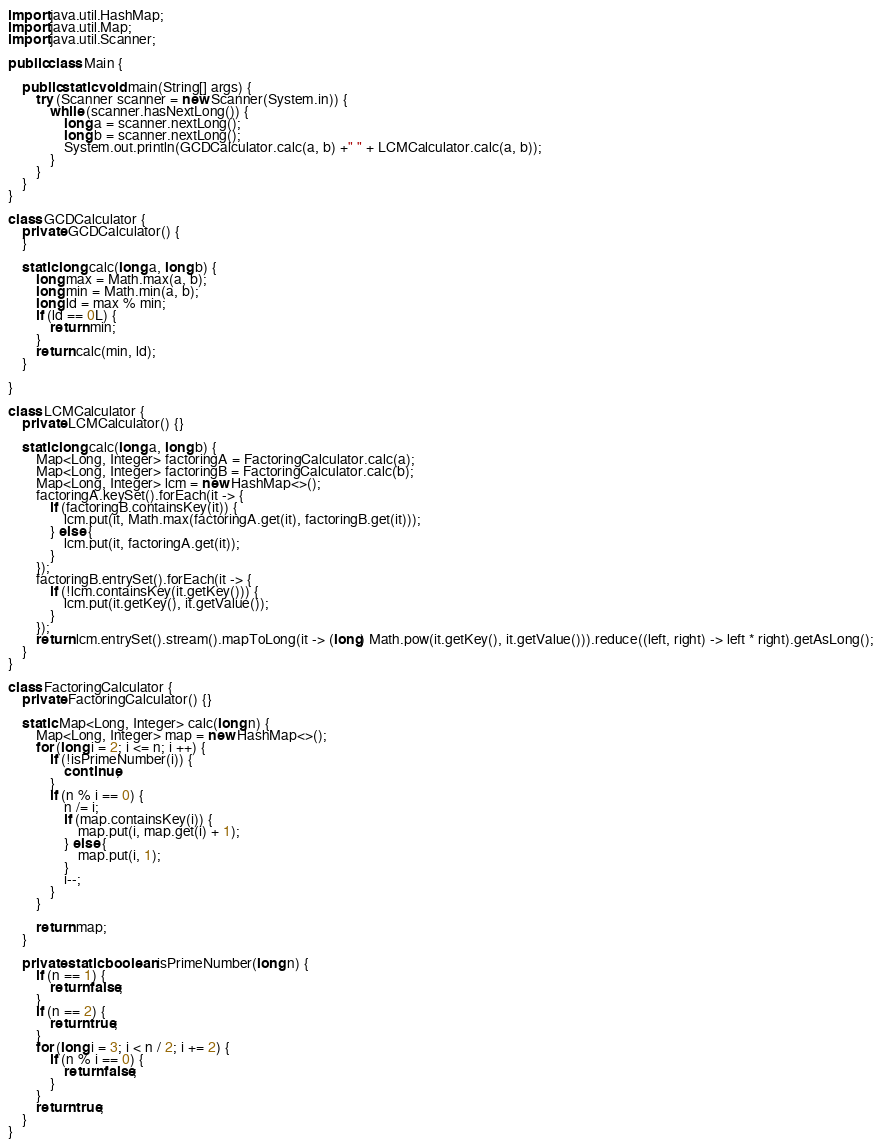<code> <loc_0><loc_0><loc_500><loc_500><_Java_>import java.util.HashMap;
import java.util.Map;
import java.util.Scanner;

public class Main {

    public static void main(String[] args) {
        try (Scanner scanner = new Scanner(System.in)) {
            while (scanner.hasNextLong()) {
                long a = scanner.nextLong();
                long b = scanner.nextLong();
                System.out.println(GCDCalculator.calc(a, b) +" " + LCMCalculator.calc(a, b));
            }
        }
    }
}

class GCDCalculator {
    private GCDCalculator() {
    }

    static long calc(long a, long b) {
        long max = Math.max(a, b);
        long min = Math.min(a, b);
        long ld = max % min;
        if (ld == 0L) {
            return min;
        }
        return calc(min, ld);
    }

}

class LCMCalculator {
    private LCMCalculator() {}

    static long calc(long a, long b) {
        Map<Long, Integer> factoringA = FactoringCalculator.calc(a);
        Map<Long, Integer> factoringB = FactoringCalculator.calc(b);
        Map<Long, Integer> lcm = new HashMap<>();
        factoringA.keySet().forEach(it -> {
            if (factoringB.containsKey(it)) {
                lcm.put(it, Math.max(factoringA.get(it), factoringB.get(it)));
            } else {
                lcm.put(it, factoringA.get(it));
            }
        });
        factoringB.entrySet().forEach(it -> {
            if (!lcm.containsKey(it.getKey())) {
                lcm.put(it.getKey(), it.getValue());
            }
        });
        return lcm.entrySet().stream().mapToLong(it -> (long) Math.pow(it.getKey(), it.getValue())).reduce((left, right) -> left * right).getAsLong();
    }
}

class FactoringCalculator {
    private FactoringCalculator() {}

    static Map<Long, Integer> calc(long n) {
        Map<Long, Integer> map = new HashMap<>();
        for (long i = 2; i <= n; i ++) {
            if (!isPrimeNumber(i)) {
                continue;
            }
            if (n % i == 0) {
                n /= i;
                if (map.containsKey(i)) {
                    map.put(i, map.get(i) + 1);
                } else {
                    map.put(i, 1);
                }
                i--;
            }
        }

        return map;
    }

    private static boolean isPrimeNumber(long n) {
        if (n == 1) {
            return false;
        }
        if (n == 2) {
            return true;
        }
        for (long i = 3; i < n / 2; i += 2) {
            if (n % i == 0) {
                return false;
            }
        }
        return true;
    }
}</code> 